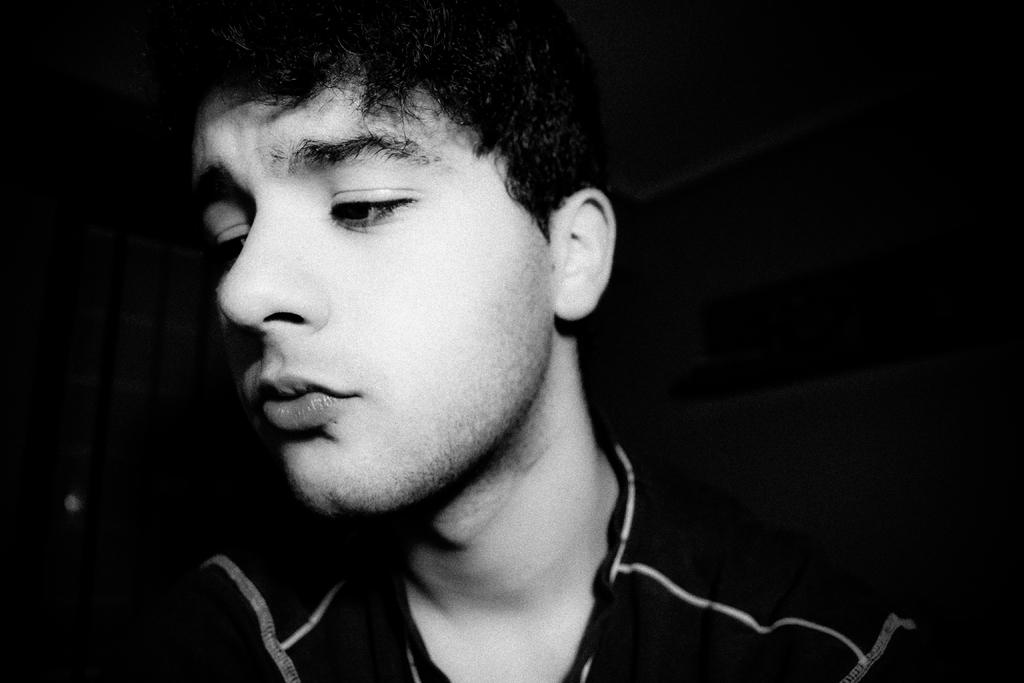Who is the main subject in the foreground of the image? There is a man in the foreground of the image. What is the color scheme of the image? The image is black and white. Can you describe the lighting conditions in the image? The man is in the dark. What type of rhythm does the toad in the image have? There is no toad present in the image, so it is not possible to determine its rhythm. 